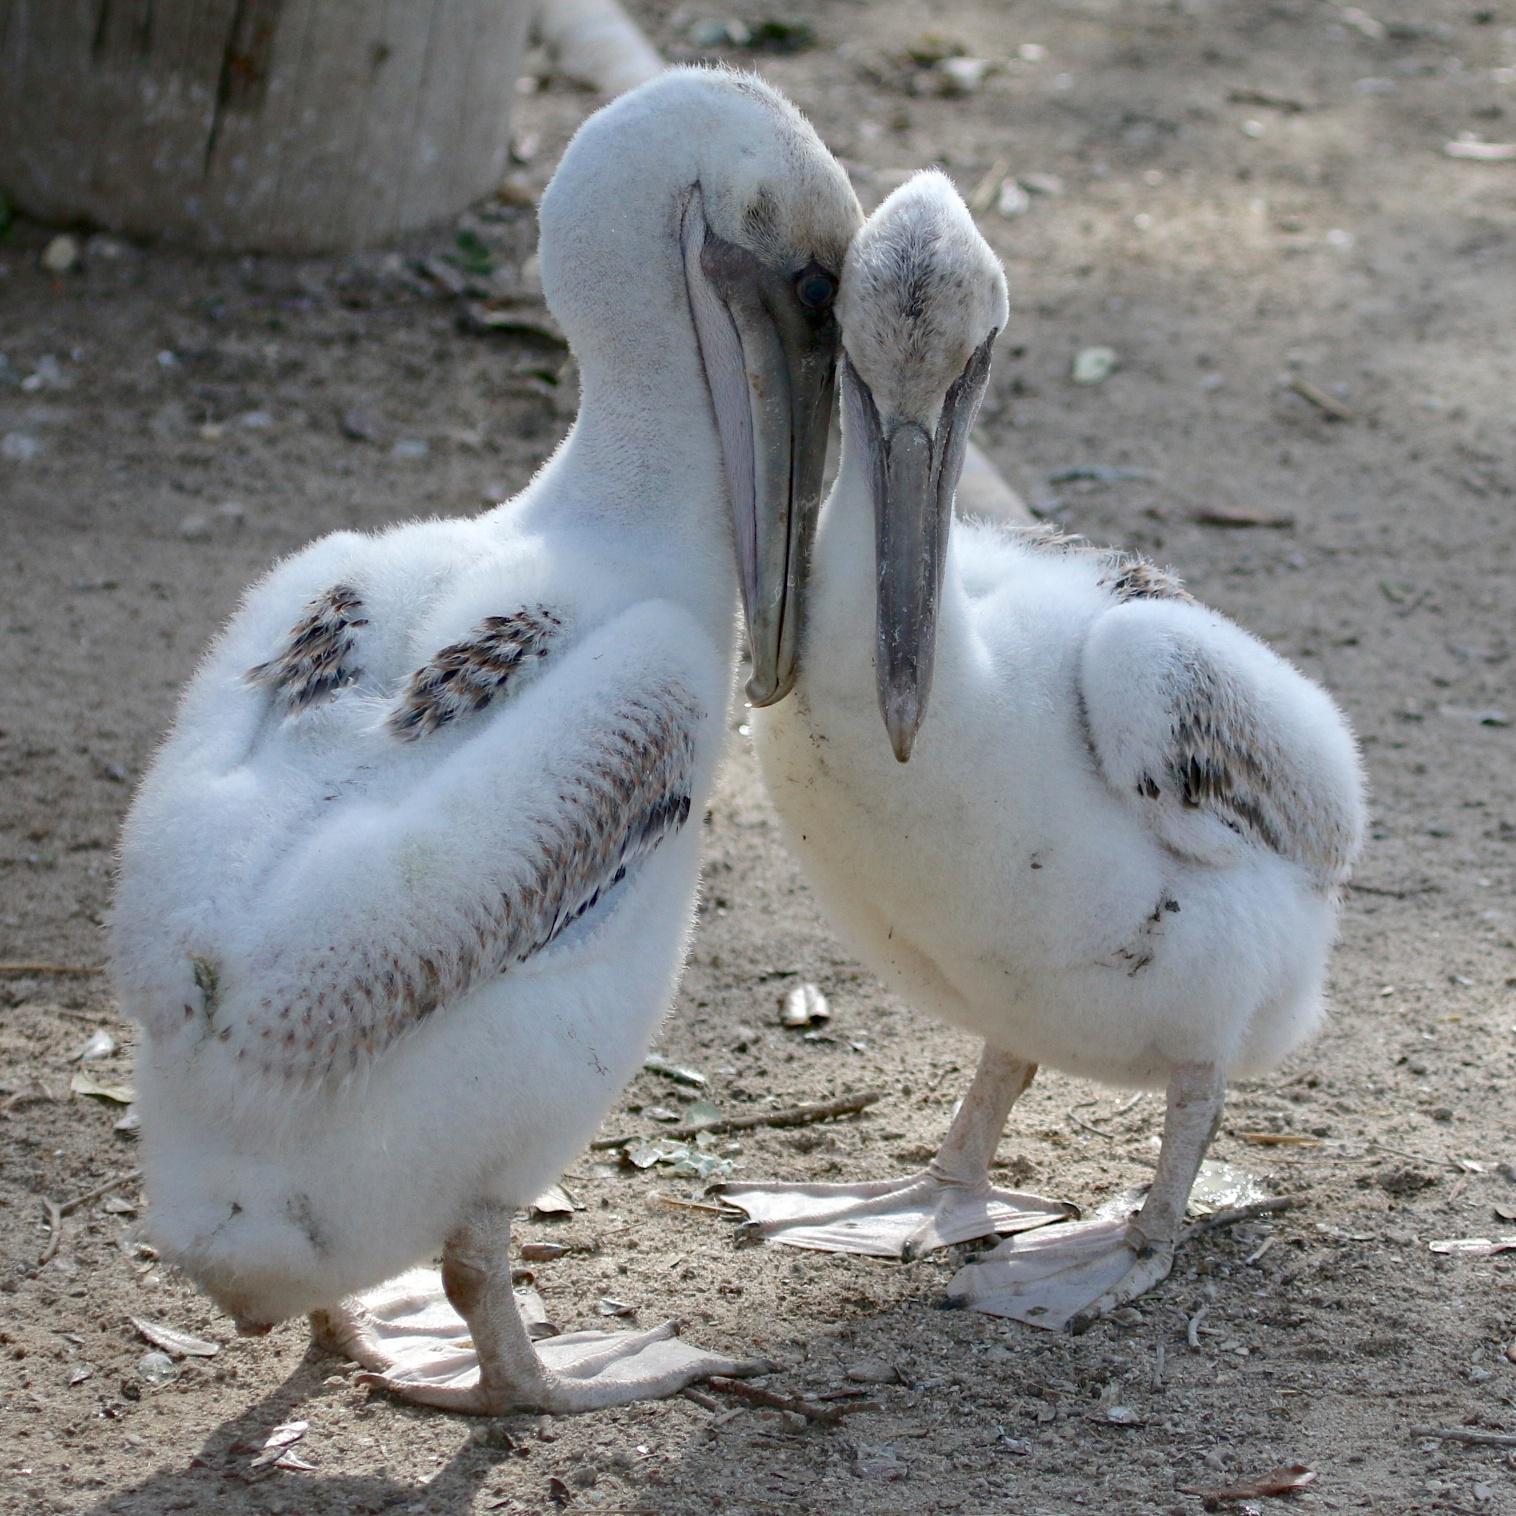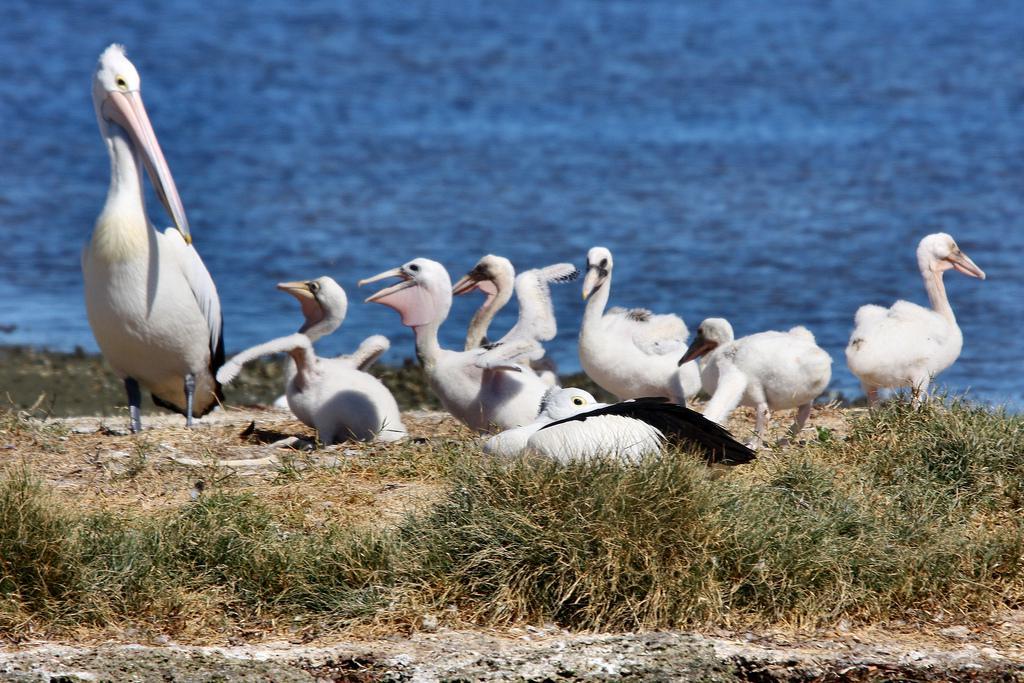The first image is the image on the left, the second image is the image on the right. Analyze the images presented: Is the assertion "An image shows exactly two juvenile pelicans with fuzzy white feathers posed close together." valid? Answer yes or no. Yes. 